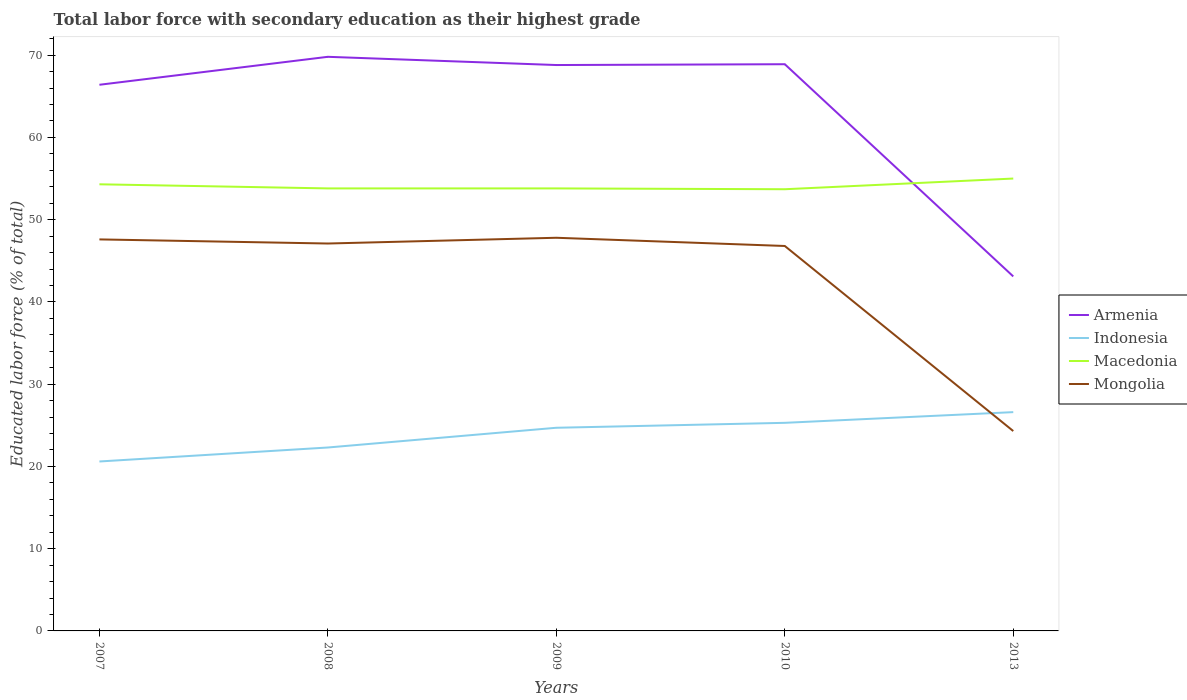How many different coloured lines are there?
Make the answer very short. 4. Across all years, what is the maximum percentage of total labor force with primary education in Macedonia?
Your answer should be compact. 53.7. In which year was the percentage of total labor force with primary education in Mongolia maximum?
Keep it short and to the point. 2013. What is the total percentage of total labor force with primary education in Macedonia in the graph?
Make the answer very short. 0.5. What is the difference between the highest and the second highest percentage of total labor force with primary education in Armenia?
Your answer should be very brief. 26.7. Is the percentage of total labor force with primary education in Macedonia strictly greater than the percentage of total labor force with primary education in Armenia over the years?
Your answer should be very brief. No. How many lines are there?
Offer a terse response. 4. What is the difference between two consecutive major ticks on the Y-axis?
Offer a very short reply. 10. Does the graph contain grids?
Keep it short and to the point. No. How many legend labels are there?
Keep it short and to the point. 4. What is the title of the graph?
Make the answer very short. Total labor force with secondary education as their highest grade. Does "Guatemala" appear as one of the legend labels in the graph?
Ensure brevity in your answer.  No. What is the label or title of the X-axis?
Make the answer very short. Years. What is the label or title of the Y-axis?
Ensure brevity in your answer.  Educated labor force (% of total). What is the Educated labor force (% of total) of Armenia in 2007?
Your response must be concise. 66.4. What is the Educated labor force (% of total) in Indonesia in 2007?
Offer a very short reply. 20.6. What is the Educated labor force (% of total) in Macedonia in 2007?
Your response must be concise. 54.3. What is the Educated labor force (% of total) in Mongolia in 2007?
Make the answer very short. 47.6. What is the Educated labor force (% of total) of Armenia in 2008?
Your answer should be compact. 69.8. What is the Educated labor force (% of total) in Indonesia in 2008?
Give a very brief answer. 22.3. What is the Educated labor force (% of total) of Macedonia in 2008?
Give a very brief answer. 53.8. What is the Educated labor force (% of total) in Mongolia in 2008?
Your answer should be very brief. 47.1. What is the Educated labor force (% of total) of Armenia in 2009?
Give a very brief answer. 68.8. What is the Educated labor force (% of total) in Indonesia in 2009?
Your response must be concise. 24.7. What is the Educated labor force (% of total) of Macedonia in 2009?
Your response must be concise. 53.8. What is the Educated labor force (% of total) in Mongolia in 2009?
Provide a short and direct response. 47.8. What is the Educated labor force (% of total) of Armenia in 2010?
Offer a very short reply. 68.9. What is the Educated labor force (% of total) of Indonesia in 2010?
Your response must be concise. 25.3. What is the Educated labor force (% of total) of Macedonia in 2010?
Give a very brief answer. 53.7. What is the Educated labor force (% of total) of Mongolia in 2010?
Keep it short and to the point. 46.8. What is the Educated labor force (% of total) in Armenia in 2013?
Keep it short and to the point. 43.1. What is the Educated labor force (% of total) of Indonesia in 2013?
Provide a succinct answer. 26.6. What is the Educated labor force (% of total) in Mongolia in 2013?
Keep it short and to the point. 24.3. Across all years, what is the maximum Educated labor force (% of total) of Armenia?
Your answer should be very brief. 69.8. Across all years, what is the maximum Educated labor force (% of total) in Indonesia?
Make the answer very short. 26.6. Across all years, what is the maximum Educated labor force (% of total) in Mongolia?
Offer a very short reply. 47.8. Across all years, what is the minimum Educated labor force (% of total) in Armenia?
Your answer should be compact. 43.1. Across all years, what is the minimum Educated labor force (% of total) in Indonesia?
Your answer should be very brief. 20.6. Across all years, what is the minimum Educated labor force (% of total) in Macedonia?
Keep it short and to the point. 53.7. Across all years, what is the minimum Educated labor force (% of total) in Mongolia?
Provide a succinct answer. 24.3. What is the total Educated labor force (% of total) of Armenia in the graph?
Provide a succinct answer. 317. What is the total Educated labor force (% of total) of Indonesia in the graph?
Offer a terse response. 119.5. What is the total Educated labor force (% of total) in Macedonia in the graph?
Provide a short and direct response. 270.6. What is the total Educated labor force (% of total) in Mongolia in the graph?
Offer a terse response. 213.6. What is the difference between the Educated labor force (% of total) in Armenia in 2007 and that in 2008?
Provide a succinct answer. -3.4. What is the difference between the Educated labor force (% of total) of Macedonia in 2007 and that in 2008?
Offer a terse response. 0.5. What is the difference between the Educated labor force (% of total) of Macedonia in 2007 and that in 2009?
Provide a short and direct response. 0.5. What is the difference between the Educated labor force (% of total) of Mongolia in 2007 and that in 2009?
Your response must be concise. -0.2. What is the difference between the Educated labor force (% of total) in Indonesia in 2007 and that in 2010?
Your answer should be very brief. -4.7. What is the difference between the Educated labor force (% of total) of Mongolia in 2007 and that in 2010?
Your response must be concise. 0.8. What is the difference between the Educated labor force (% of total) in Armenia in 2007 and that in 2013?
Make the answer very short. 23.3. What is the difference between the Educated labor force (% of total) of Indonesia in 2007 and that in 2013?
Make the answer very short. -6. What is the difference between the Educated labor force (% of total) of Macedonia in 2007 and that in 2013?
Provide a succinct answer. -0.7. What is the difference between the Educated labor force (% of total) in Mongolia in 2007 and that in 2013?
Your answer should be very brief. 23.3. What is the difference between the Educated labor force (% of total) of Indonesia in 2008 and that in 2010?
Offer a very short reply. -3. What is the difference between the Educated labor force (% of total) in Armenia in 2008 and that in 2013?
Keep it short and to the point. 26.7. What is the difference between the Educated labor force (% of total) in Mongolia in 2008 and that in 2013?
Offer a terse response. 22.8. What is the difference between the Educated labor force (% of total) in Armenia in 2009 and that in 2010?
Provide a short and direct response. -0.1. What is the difference between the Educated labor force (% of total) in Indonesia in 2009 and that in 2010?
Give a very brief answer. -0.6. What is the difference between the Educated labor force (% of total) of Macedonia in 2009 and that in 2010?
Offer a terse response. 0.1. What is the difference between the Educated labor force (% of total) of Mongolia in 2009 and that in 2010?
Provide a succinct answer. 1. What is the difference between the Educated labor force (% of total) of Armenia in 2009 and that in 2013?
Your answer should be compact. 25.7. What is the difference between the Educated labor force (% of total) of Mongolia in 2009 and that in 2013?
Your answer should be very brief. 23.5. What is the difference between the Educated labor force (% of total) in Armenia in 2010 and that in 2013?
Your answer should be very brief. 25.8. What is the difference between the Educated labor force (% of total) in Indonesia in 2010 and that in 2013?
Ensure brevity in your answer.  -1.3. What is the difference between the Educated labor force (% of total) of Mongolia in 2010 and that in 2013?
Offer a very short reply. 22.5. What is the difference between the Educated labor force (% of total) of Armenia in 2007 and the Educated labor force (% of total) of Indonesia in 2008?
Your response must be concise. 44.1. What is the difference between the Educated labor force (% of total) in Armenia in 2007 and the Educated labor force (% of total) in Mongolia in 2008?
Keep it short and to the point. 19.3. What is the difference between the Educated labor force (% of total) in Indonesia in 2007 and the Educated labor force (% of total) in Macedonia in 2008?
Offer a very short reply. -33.2. What is the difference between the Educated labor force (% of total) in Indonesia in 2007 and the Educated labor force (% of total) in Mongolia in 2008?
Provide a succinct answer. -26.5. What is the difference between the Educated labor force (% of total) in Macedonia in 2007 and the Educated labor force (% of total) in Mongolia in 2008?
Keep it short and to the point. 7.2. What is the difference between the Educated labor force (% of total) in Armenia in 2007 and the Educated labor force (% of total) in Indonesia in 2009?
Offer a very short reply. 41.7. What is the difference between the Educated labor force (% of total) of Armenia in 2007 and the Educated labor force (% of total) of Mongolia in 2009?
Make the answer very short. 18.6. What is the difference between the Educated labor force (% of total) in Indonesia in 2007 and the Educated labor force (% of total) in Macedonia in 2009?
Give a very brief answer. -33.2. What is the difference between the Educated labor force (% of total) in Indonesia in 2007 and the Educated labor force (% of total) in Mongolia in 2009?
Your response must be concise. -27.2. What is the difference between the Educated labor force (% of total) of Armenia in 2007 and the Educated labor force (% of total) of Indonesia in 2010?
Ensure brevity in your answer.  41.1. What is the difference between the Educated labor force (% of total) in Armenia in 2007 and the Educated labor force (% of total) in Mongolia in 2010?
Keep it short and to the point. 19.6. What is the difference between the Educated labor force (% of total) of Indonesia in 2007 and the Educated labor force (% of total) of Macedonia in 2010?
Make the answer very short. -33.1. What is the difference between the Educated labor force (% of total) of Indonesia in 2007 and the Educated labor force (% of total) of Mongolia in 2010?
Give a very brief answer. -26.2. What is the difference between the Educated labor force (% of total) of Armenia in 2007 and the Educated labor force (% of total) of Indonesia in 2013?
Keep it short and to the point. 39.8. What is the difference between the Educated labor force (% of total) in Armenia in 2007 and the Educated labor force (% of total) in Mongolia in 2013?
Make the answer very short. 42.1. What is the difference between the Educated labor force (% of total) in Indonesia in 2007 and the Educated labor force (% of total) in Macedonia in 2013?
Your response must be concise. -34.4. What is the difference between the Educated labor force (% of total) in Indonesia in 2007 and the Educated labor force (% of total) in Mongolia in 2013?
Your response must be concise. -3.7. What is the difference between the Educated labor force (% of total) in Macedonia in 2007 and the Educated labor force (% of total) in Mongolia in 2013?
Keep it short and to the point. 30. What is the difference between the Educated labor force (% of total) in Armenia in 2008 and the Educated labor force (% of total) in Indonesia in 2009?
Provide a short and direct response. 45.1. What is the difference between the Educated labor force (% of total) of Armenia in 2008 and the Educated labor force (% of total) of Macedonia in 2009?
Provide a succinct answer. 16. What is the difference between the Educated labor force (% of total) in Indonesia in 2008 and the Educated labor force (% of total) in Macedonia in 2009?
Ensure brevity in your answer.  -31.5. What is the difference between the Educated labor force (% of total) in Indonesia in 2008 and the Educated labor force (% of total) in Mongolia in 2009?
Your response must be concise. -25.5. What is the difference between the Educated labor force (% of total) in Macedonia in 2008 and the Educated labor force (% of total) in Mongolia in 2009?
Make the answer very short. 6. What is the difference between the Educated labor force (% of total) of Armenia in 2008 and the Educated labor force (% of total) of Indonesia in 2010?
Offer a terse response. 44.5. What is the difference between the Educated labor force (% of total) in Armenia in 2008 and the Educated labor force (% of total) in Macedonia in 2010?
Your answer should be very brief. 16.1. What is the difference between the Educated labor force (% of total) in Armenia in 2008 and the Educated labor force (% of total) in Mongolia in 2010?
Your response must be concise. 23. What is the difference between the Educated labor force (% of total) of Indonesia in 2008 and the Educated labor force (% of total) of Macedonia in 2010?
Make the answer very short. -31.4. What is the difference between the Educated labor force (% of total) of Indonesia in 2008 and the Educated labor force (% of total) of Mongolia in 2010?
Offer a terse response. -24.5. What is the difference between the Educated labor force (% of total) in Macedonia in 2008 and the Educated labor force (% of total) in Mongolia in 2010?
Ensure brevity in your answer.  7. What is the difference between the Educated labor force (% of total) in Armenia in 2008 and the Educated labor force (% of total) in Indonesia in 2013?
Your answer should be very brief. 43.2. What is the difference between the Educated labor force (% of total) of Armenia in 2008 and the Educated labor force (% of total) of Mongolia in 2013?
Give a very brief answer. 45.5. What is the difference between the Educated labor force (% of total) of Indonesia in 2008 and the Educated labor force (% of total) of Macedonia in 2013?
Make the answer very short. -32.7. What is the difference between the Educated labor force (% of total) in Macedonia in 2008 and the Educated labor force (% of total) in Mongolia in 2013?
Give a very brief answer. 29.5. What is the difference between the Educated labor force (% of total) in Armenia in 2009 and the Educated labor force (% of total) in Indonesia in 2010?
Offer a terse response. 43.5. What is the difference between the Educated labor force (% of total) of Indonesia in 2009 and the Educated labor force (% of total) of Macedonia in 2010?
Make the answer very short. -29. What is the difference between the Educated labor force (% of total) of Indonesia in 2009 and the Educated labor force (% of total) of Mongolia in 2010?
Ensure brevity in your answer.  -22.1. What is the difference between the Educated labor force (% of total) in Macedonia in 2009 and the Educated labor force (% of total) in Mongolia in 2010?
Your answer should be compact. 7. What is the difference between the Educated labor force (% of total) of Armenia in 2009 and the Educated labor force (% of total) of Indonesia in 2013?
Make the answer very short. 42.2. What is the difference between the Educated labor force (% of total) of Armenia in 2009 and the Educated labor force (% of total) of Mongolia in 2013?
Provide a short and direct response. 44.5. What is the difference between the Educated labor force (% of total) in Indonesia in 2009 and the Educated labor force (% of total) in Macedonia in 2013?
Ensure brevity in your answer.  -30.3. What is the difference between the Educated labor force (% of total) of Indonesia in 2009 and the Educated labor force (% of total) of Mongolia in 2013?
Keep it short and to the point. 0.4. What is the difference between the Educated labor force (% of total) of Macedonia in 2009 and the Educated labor force (% of total) of Mongolia in 2013?
Offer a terse response. 29.5. What is the difference between the Educated labor force (% of total) in Armenia in 2010 and the Educated labor force (% of total) in Indonesia in 2013?
Provide a succinct answer. 42.3. What is the difference between the Educated labor force (% of total) in Armenia in 2010 and the Educated labor force (% of total) in Macedonia in 2013?
Make the answer very short. 13.9. What is the difference between the Educated labor force (% of total) in Armenia in 2010 and the Educated labor force (% of total) in Mongolia in 2013?
Give a very brief answer. 44.6. What is the difference between the Educated labor force (% of total) of Indonesia in 2010 and the Educated labor force (% of total) of Macedonia in 2013?
Ensure brevity in your answer.  -29.7. What is the difference between the Educated labor force (% of total) of Indonesia in 2010 and the Educated labor force (% of total) of Mongolia in 2013?
Keep it short and to the point. 1. What is the difference between the Educated labor force (% of total) of Macedonia in 2010 and the Educated labor force (% of total) of Mongolia in 2013?
Your answer should be very brief. 29.4. What is the average Educated labor force (% of total) in Armenia per year?
Your answer should be very brief. 63.4. What is the average Educated labor force (% of total) in Indonesia per year?
Give a very brief answer. 23.9. What is the average Educated labor force (% of total) in Macedonia per year?
Offer a very short reply. 54.12. What is the average Educated labor force (% of total) in Mongolia per year?
Ensure brevity in your answer.  42.72. In the year 2007, what is the difference between the Educated labor force (% of total) in Armenia and Educated labor force (% of total) in Indonesia?
Your answer should be very brief. 45.8. In the year 2007, what is the difference between the Educated labor force (% of total) in Indonesia and Educated labor force (% of total) in Macedonia?
Ensure brevity in your answer.  -33.7. In the year 2008, what is the difference between the Educated labor force (% of total) of Armenia and Educated labor force (% of total) of Indonesia?
Provide a short and direct response. 47.5. In the year 2008, what is the difference between the Educated labor force (% of total) of Armenia and Educated labor force (% of total) of Macedonia?
Provide a short and direct response. 16. In the year 2008, what is the difference between the Educated labor force (% of total) of Armenia and Educated labor force (% of total) of Mongolia?
Your answer should be very brief. 22.7. In the year 2008, what is the difference between the Educated labor force (% of total) in Indonesia and Educated labor force (% of total) in Macedonia?
Ensure brevity in your answer.  -31.5. In the year 2008, what is the difference between the Educated labor force (% of total) of Indonesia and Educated labor force (% of total) of Mongolia?
Offer a very short reply. -24.8. In the year 2008, what is the difference between the Educated labor force (% of total) of Macedonia and Educated labor force (% of total) of Mongolia?
Your answer should be very brief. 6.7. In the year 2009, what is the difference between the Educated labor force (% of total) of Armenia and Educated labor force (% of total) of Indonesia?
Ensure brevity in your answer.  44.1. In the year 2009, what is the difference between the Educated labor force (% of total) of Armenia and Educated labor force (% of total) of Mongolia?
Give a very brief answer. 21. In the year 2009, what is the difference between the Educated labor force (% of total) in Indonesia and Educated labor force (% of total) in Macedonia?
Your answer should be compact. -29.1. In the year 2009, what is the difference between the Educated labor force (% of total) of Indonesia and Educated labor force (% of total) of Mongolia?
Offer a terse response. -23.1. In the year 2010, what is the difference between the Educated labor force (% of total) in Armenia and Educated labor force (% of total) in Indonesia?
Ensure brevity in your answer.  43.6. In the year 2010, what is the difference between the Educated labor force (% of total) of Armenia and Educated labor force (% of total) of Macedonia?
Give a very brief answer. 15.2. In the year 2010, what is the difference between the Educated labor force (% of total) in Armenia and Educated labor force (% of total) in Mongolia?
Keep it short and to the point. 22.1. In the year 2010, what is the difference between the Educated labor force (% of total) of Indonesia and Educated labor force (% of total) of Macedonia?
Provide a short and direct response. -28.4. In the year 2010, what is the difference between the Educated labor force (% of total) of Indonesia and Educated labor force (% of total) of Mongolia?
Keep it short and to the point. -21.5. In the year 2013, what is the difference between the Educated labor force (% of total) in Armenia and Educated labor force (% of total) in Indonesia?
Provide a succinct answer. 16.5. In the year 2013, what is the difference between the Educated labor force (% of total) of Armenia and Educated labor force (% of total) of Mongolia?
Ensure brevity in your answer.  18.8. In the year 2013, what is the difference between the Educated labor force (% of total) in Indonesia and Educated labor force (% of total) in Macedonia?
Make the answer very short. -28.4. In the year 2013, what is the difference between the Educated labor force (% of total) of Indonesia and Educated labor force (% of total) of Mongolia?
Provide a succinct answer. 2.3. In the year 2013, what is the difference between the Educated labor force (% of total) of Macedonia and Educated labor force (% of total) of Mongolia?
Your answer should be compact. 30.7. What is the ratio of the Educated labor force (% of total) of Armenia in 2007 to that in 2008?
Offer a very short reply. 0.95. What is the ratio of the Educated labor force (% of total) of Indonesia in 2007 to that in 2008?
Provide a short and direct response. 0.92. What is the ratio of the Educated labor force (% of total) in Macedonia in 2007 to that in 2008?
Provide a short and direct response. 1.01. What is the ratio of the Educated labor force (% of total) of Mongolia in 2007 to that in 2008?
Keep it short and to the point. 1.01. What is the ratio of the Educated labor force (% of total) of Armenia in 2007 to that in 2009?
Offer a very short reply. 0.97. What is the ratio of the Educated labor force (% of total) in Indonesia in 2007 to that in 2009?
Your response must be concise. 0.83. What is the ratio of the Educated labor force (% of total) in Macedonia in 2007 to that in 2009?
Provide a succinct answer. 1.01. What is the ratio of the Educated labor force (% of total) of Armenia in 2007 to that in 2010?
Provide a short and direct response. 0.96. What is the ratio of the Educated labor force (% of total) in Indonesia in 2007 to that in 2010?
Your answer should be very brief. 0.81. What is the ratio of the Educated labor force (% of total) of Macedonia in 2007 to that in 2010?
Offer a terse response. 1.01. What is the ratio of the Educated labor force (% of total) in Mongolia in 2007 to that in 2010?
Provide a succinct answer. 1.02. What is the ratio of the Educated labor force (% of total) in Armenia in 2007 to that in 2013?
Your response must be concise. 1.54. What is the ratio of the Educated labor force (% of total) of Indonesia in 2007 to that in 2013?
Your response must be concise. 0.77. What is the ratio of the Educated labor force (% of total) of Macedonia in 2007 to that in 2013?
Ensure brevity in your answer.  0.99. What is the ratio of the Educated labor force (% of total) of Mongolia in 2007 to that in 2013?
Your answer should be compact. 1.96. What is the ratio of the Educated labor force (% of total) in Armenia in 2008 to that in 2009?
Give a very brief answer. 1.01. What is the ratio of the Educated labor force (% of total) in Indonesia in 2008 to that in 2009?
Offer a very short reply. 0.9. What is the ratio of the Educated labor force (% of total) in Mongolia in 2008 to that in 2009?
Offer a terse response. 0.99. What is the ratio of the Educated labor force (% of total) in Armenia in 2008 to that in 2010?
Your answer should be compact. 1.01. What is the ratio of the Educated labor force (% of total) in Indonesia in 2008 to that in 2010?
Provide a succinct answer. 0.88. What is the ratio of the Educated labor force (% of total) of Macedonia in 2008 to that in 2010?
Provide a succinct answer. 1. What is the ratio of the Educated labor force (% of total) in Mongolia in 2008 to that in 2010?
Ensure brevity in your answer.  1.01. What is the ratio of the Educated labor force (% of total) in Armenia in 2008 to that in 2013?
Your answer should be very brief. 1.62. What is the ratio of the Educated labor force (% of total) in Indonesia in 2008 to that in 2013?
Your answer should be very brief. 0.84. What is the ratio of the Educated labor force (% of total) of Macedonia in 2008 to that in 2013?
Offer a very short reply. 0.98. What is the ratio of the Educated labor force (% of total) in Mongolia in 2008 to that in 2013?
Ensure brevity in your answer.  1.94. What is the ratio of the Educated labor force (% of total) in Armenia in 2009 to that in 2010?
Your response must be concise. 1. What is the ratio of the Educated labor force (% of total) of Indonesia in 2009 to that in 2010?
Offer a very short reply. 0.98. What is the ratio of the Educated labor force (% of total) of Macedonia in 2009 to that in 2010?
Give a very brief answer. 1. What is the ratio of the Educated labor force (% of total) in Mongolia in 2009 to that in 2010?
Offer a very short reply. 1.02. What is the ratio of the Educated labor force (% of total) in Armenia in 2009 to that in 2013?
Offer a terse response. 1.6. What is the ratio of the Educated labor force (% of total) of Macedonia in 2009 to that in 2013?
Provide a succinct answer. 0.98. What is the ratio of the Educated labor force (% of total) of Mongolia in 2009 to that in 2013?
Give a very brief answer. 1.97. What is the ratio of the Educated labor force (% of total) of Armenia in 2010 to that in 2013?
Your answer should be very brief. 1.6. What is the ratio of the Educated labor force (% of total) of Indonesia in 2010 to that in 2013?
Your answer should be very brief. 0.95. What is the ratio of the Educated labor force (% of total) of Macedonia in 2010 to that in 2013?
Offer a very short reply. 0.98. What is the ratio of the Educated labor force (% of total) of Mongolia in 2010 to that in 2013?
Your answer should be very brief. 1.93. What is the difference between the highest and the second highest Educated labor force (% of total) of Armenia?
Give a very brief answer. 0.9. What is the difference between the highest and the second highest Educated labor force (% of total) of Macedonia?
Give a very brief answer. 0.7. What is the difference between the highest and the lowest Educated labor force (% of total) of Armenia?
Keep it short and to the point. 26.7. What is the difference between the highest and the lowest Educated labor force (% of total) in Indonesia?
Make the answer very short. 6. What is the difference between the highest and the lowest Educated labor force (% of total) of Macedonia?
Offer a terse response. 1.3. 